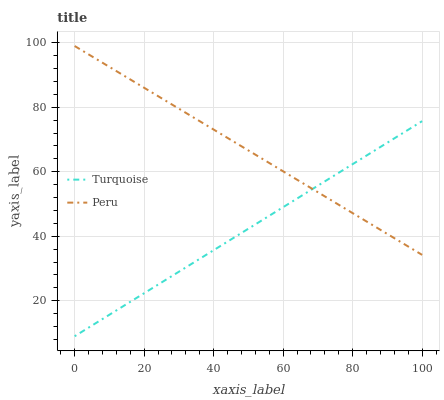Does Turquoise have the minimum area under the curve?
Answer yes or no. Yes. Does Peru have the maximum area under the curve?
Answer yes or no. Yes. Does Peru have the minimum area under the curve?
Answer yes or no. No. Is Turquoise the smoothest?
Answer yes or no. Yes. Is Peru the roughest?
Answer yes or no. Yes. Is Peru the smoothest?
Answer yes or no. No. Does Turquoise have the lowest value?
Answer yes or no. Yes. Does Peru have the lowest value?
Answer yes or no. No. Does Peru have the highest value?
Answer yes or no. Yes. Does Peru intersect Turquoise?
Answer yes or no. Yes. Is Peru less than Turquoise?
Answer yes or no. No. Is Peru greater than Turquoise?
Answer yes or no. No. 